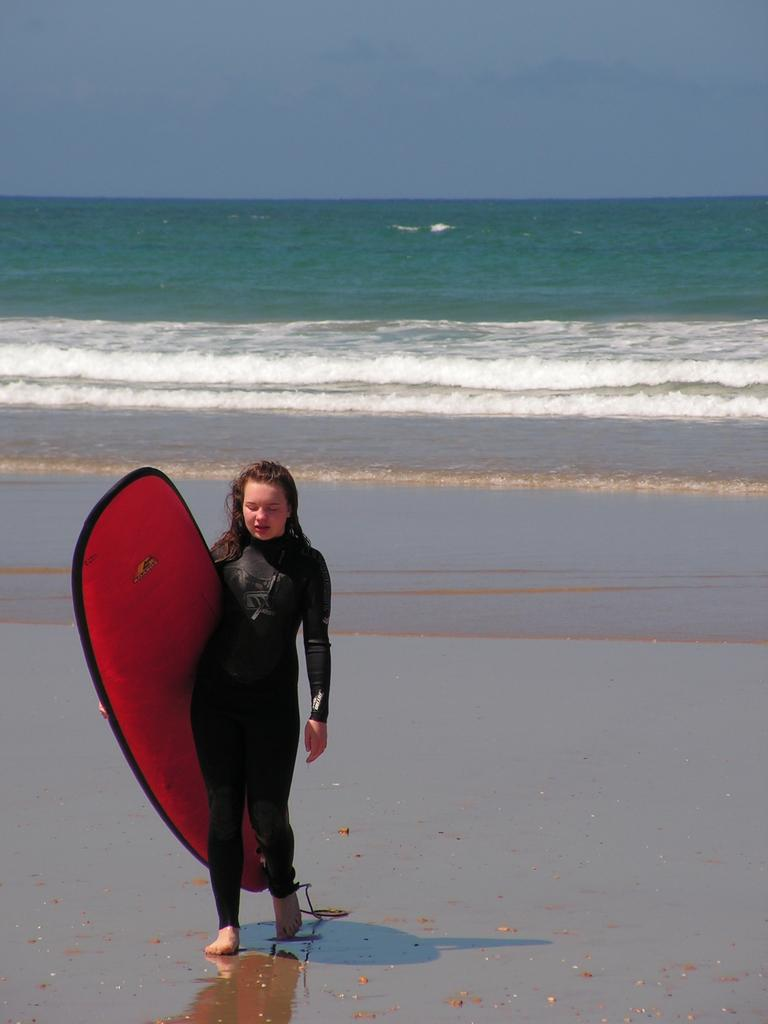Who is present in the image? There is a woman in the image. What is the woman doing in the image? The woman is walking on the beach. What is the woman holding in the image? The woman is holding a surf boat. What can be seen in the background of the image? There is water and the sky visible in the background. What type of doctor can be seen in the image? There is no doctor present in the image; it features a woman walking on the beach with a surf boat. What color is the kite flying in the sky in the image? There is no kite present in the image; only the woman, surf boat, water, and sky are visible. 